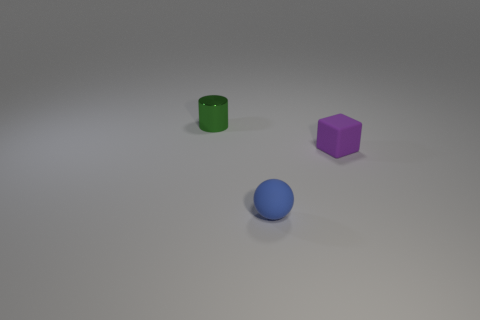Add 3 small cyan matte cylinders. How many objects exist? 6 Subtract all cylinders. How many objects are left? 2 Subtract all rubber cubes. Subtract all purple cubes. How many objects are left? 1 Add 1 tiny blue objects. How many tiny blue objects are left? 2 Add 3 purple rubber objects. How many purple rubber objects exist? 4 Subtract 0 blue cylinders. How many objects are left? 3 